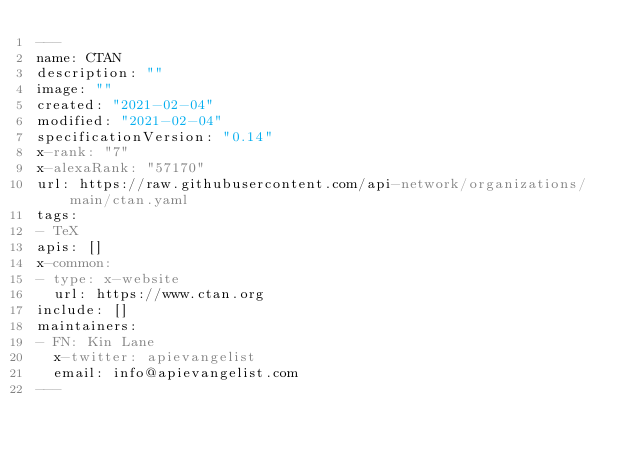<code> <loc_0><loc_0><loc_500><loc_500><_YAML_>---
name: CTAN
description: ""
image: ""
created: "2021-02-04"
modified: "2021-02-04"
specificationVersion: "0.14"
x-rank: "7"
x-alexaRank: "57170"
url: https://raw.githubusercontent.com/api-network/organizations/main/ctan.yaml
tags:
- TeX
apis: []
x-common:
- type: x-website
  url: https://www.ctan.org
include: []
maintainers:
- FN: Kin Lane
  x-twitter: apievangelist
  email: info@apievangelist.com
---</code> 